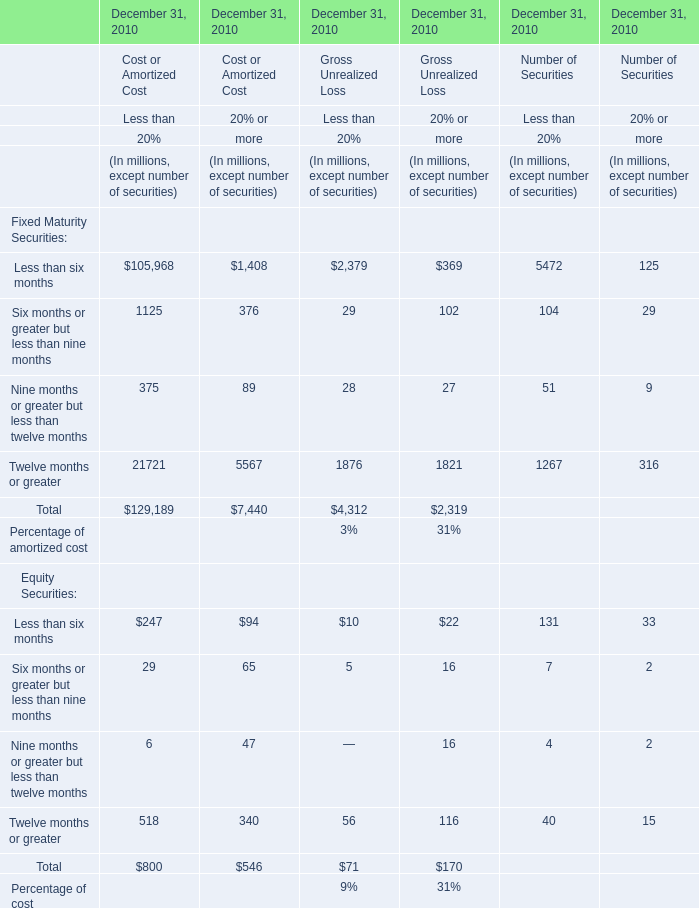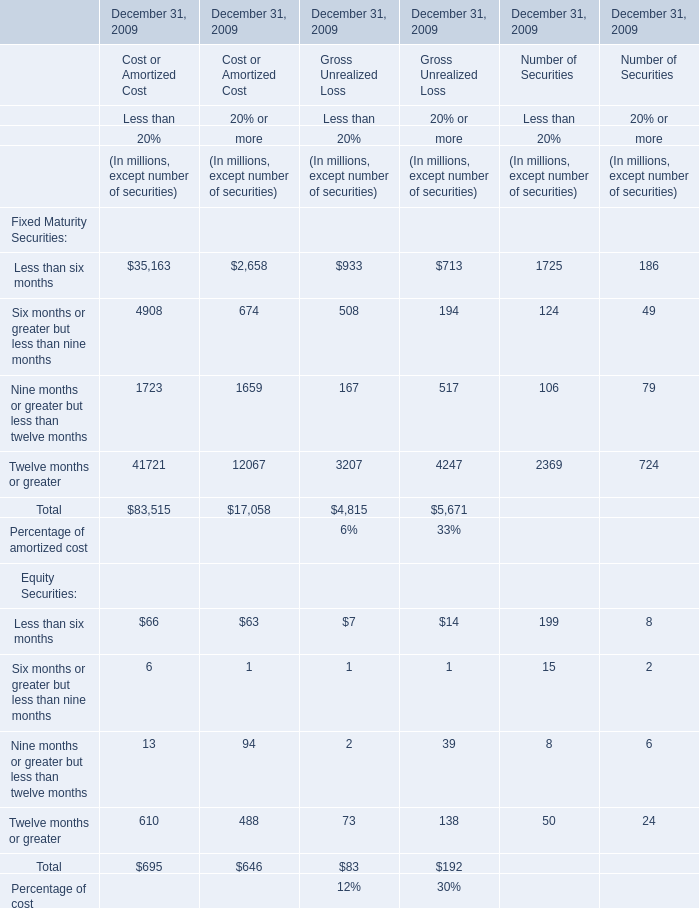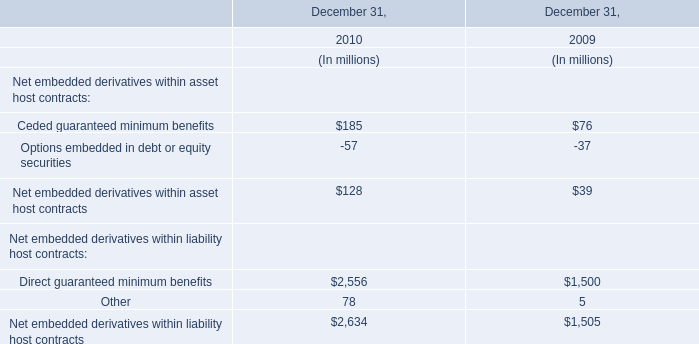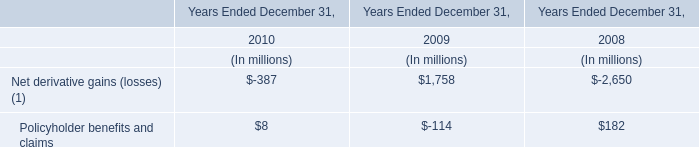What's the 10% of total elements for Gross Unrealized Loss of Less than Less than 20% in 2009? (in million) 
Computations: ((4815 + 83) * 0.1)
Answer: 489.8. 